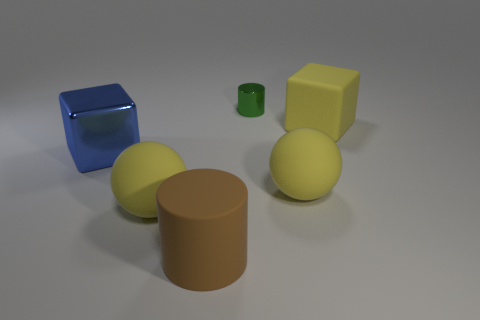Is the shape of the blue shiny thing the same as the large yellow rubber object behind the big blue thing?
Your answer should be very brief. Yes. How many rubber things are blue objects or yellow spheres?
Provide a succinct answer. 2. There is a large cube on the right side of the block that is to the left of the big yellow matte object that is left of the small object; what color is it?
Make the answer very short. Yellow. What number of other objects are the same material as the large blue cube?
Your response must be concise. 1. There is a big yellow rubber object that is behind the blue block; is its shape the same as the tiny object?
Give a very brief answer. No. How many small things are either green cylinders or yellow objects?
Your answer should be compact. 1. Are there the same number of large blue metal things right of the green metallic thing and cubes in front of the big yellow cube?
Give a very brief answer. No. How many other objects are the same color as the small shiny object?
Provide a short and direct response. 0. There is a large rubber cube; does it have the same color as the rubber sphere that is on the right side of the large brown cylinder?
Make the answer very short. Yes. How many yellow things are either large rubber objects or tiny metallic cylinders?
Your answer should be very brief. 3. 